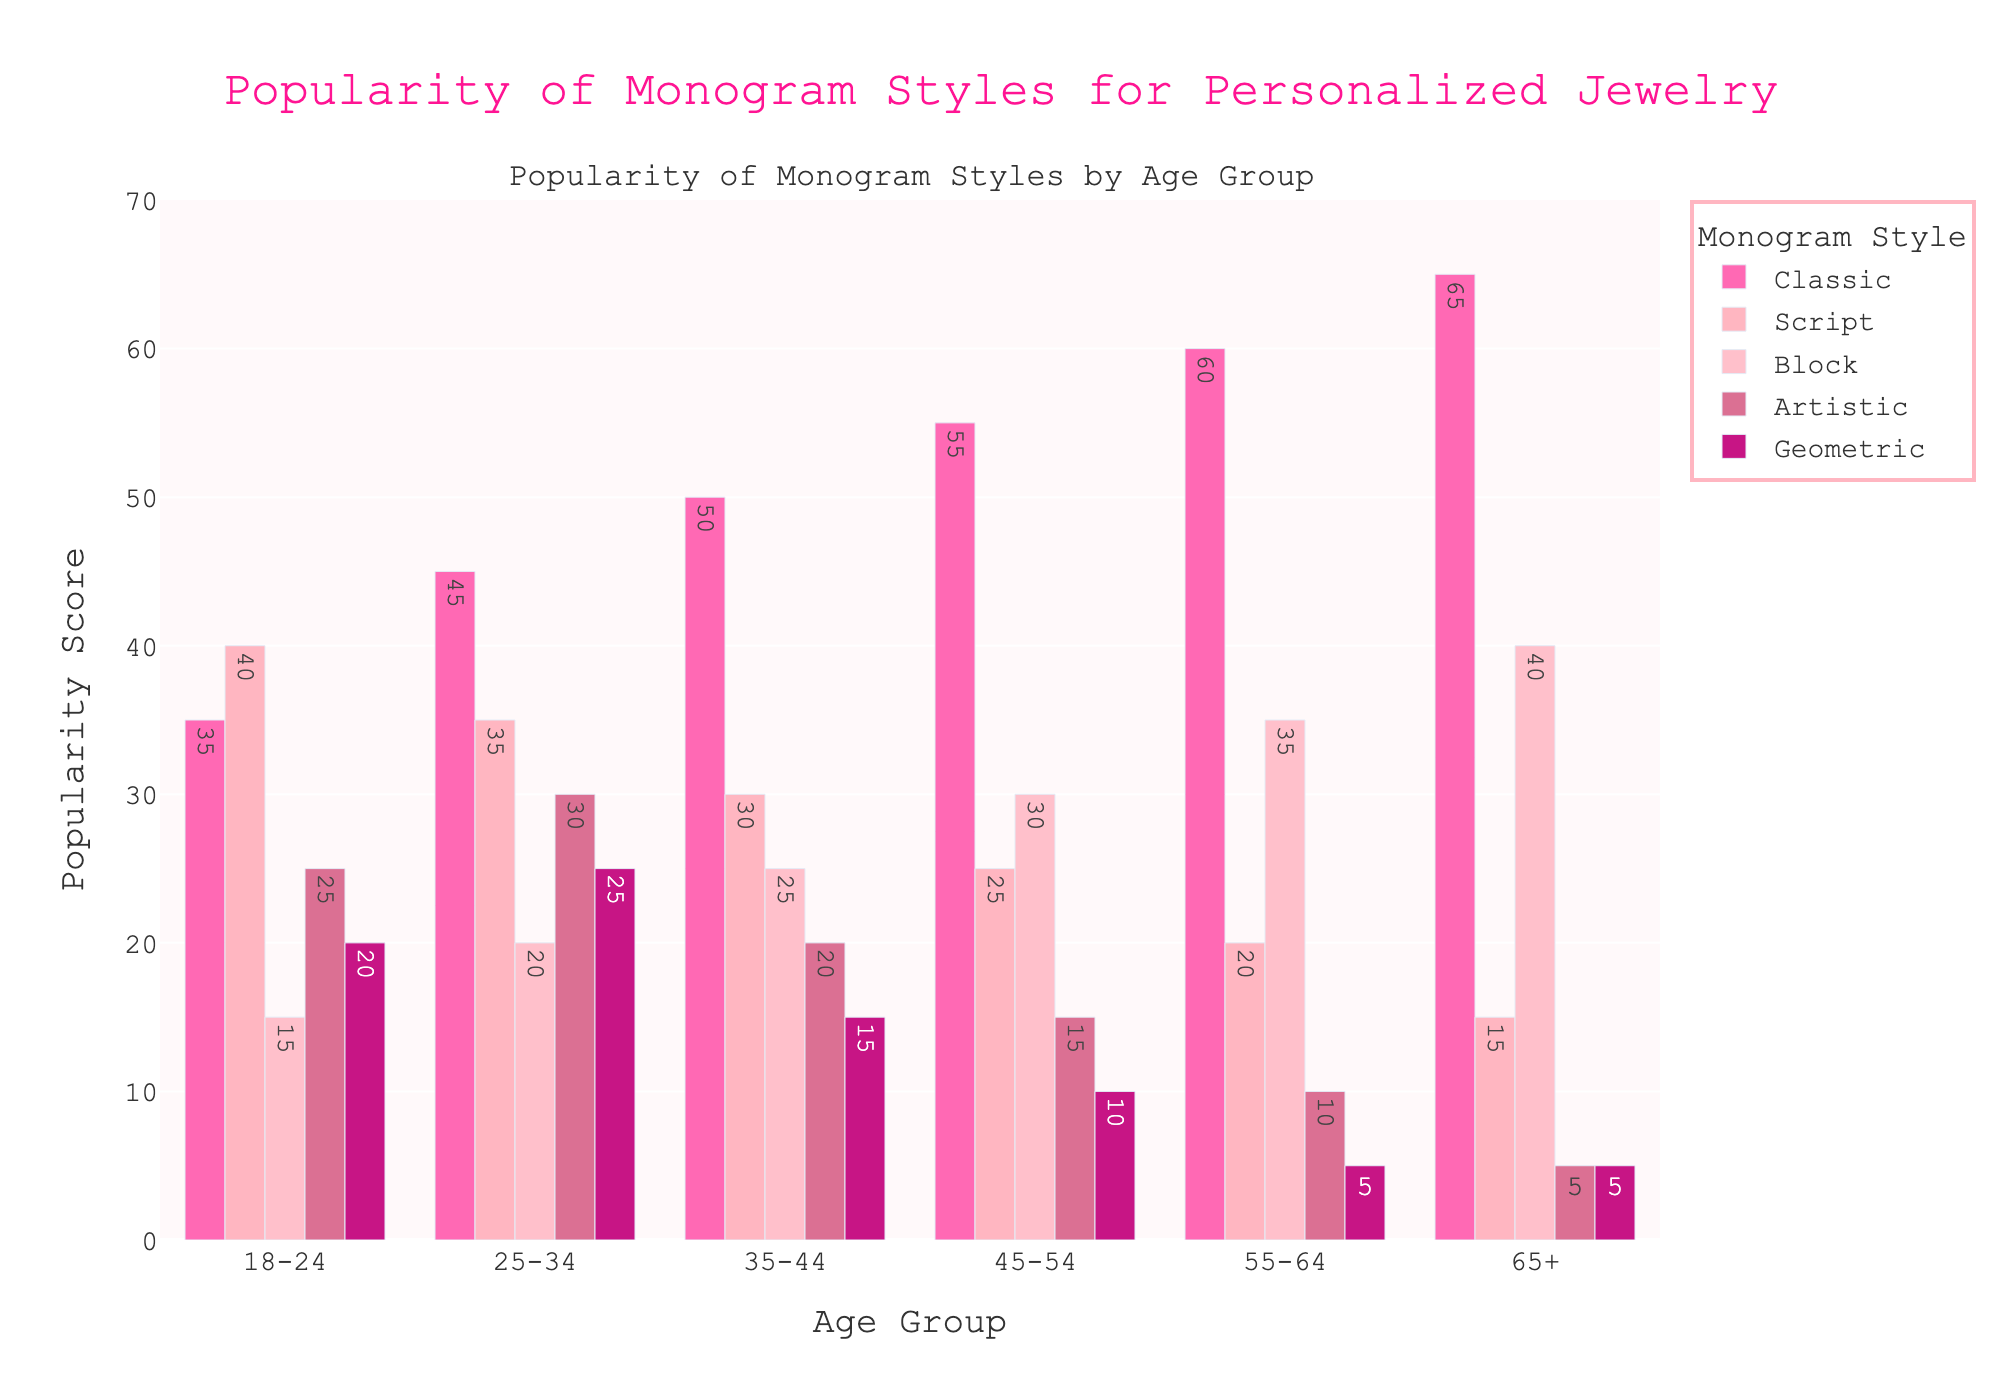Which age group prefers the classic monogram style the most? By examining the height of the Classic bars, the oldest age group (65+) shows the highest bar visible in the Classic category.
Answer: 65+ What is the difference in popularity of the artistic monogram style between the 18-24 and 65+ age groups? Identify the Artistic values for both age groups: 25 (18-24) and 5 (65+). Subtracting these gives 25 - 5 = 20.
Answer: 20 Among all age groups, which monogram style is the least popular? The least popular overall are the smallest bars across all age groups. Geometric for 55-64 and 65+ has the lowest consistent height, with values of 5 each.
Answer: Geometric What is the average popularity score of the script monogram style across all age groups? Add all the Script values: 40 + 35 + 30 + 25 + 20 + 15 = 165. There are 6 age groups, so the average is 165/6 = 27.5.
Answer: 27.5 How much more popular is the block monogram style for the age group 55-64 compared to the 18-24 age group? The Block values for 55-64 and 18-24 are 35 and 15, respectively. Calculate the difference: 35 - 15 = 20.
Answer: 20 What is the combined popularity score of all monogram styles for the age group 35-44? Sum the values for each style in the 35-44 category: 50 + 30 + 25 + 20 + 15 = 140.
Answer: 140 